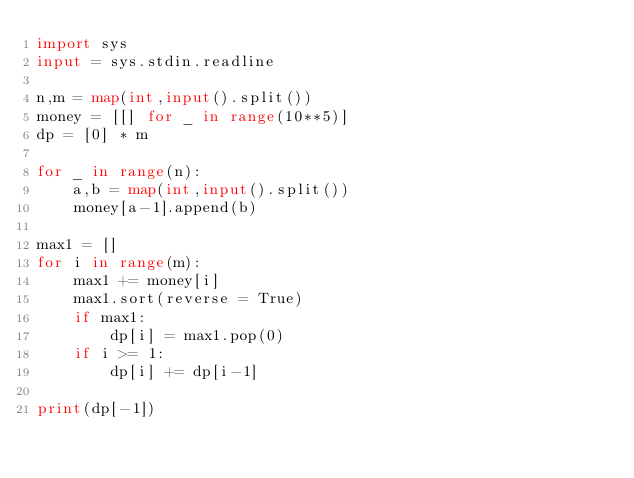Convert code to text. <code><loc_0><loc_0><loc_500><loc_500><_Python_>import sys
input = sys.stdin.readline

n,m = map(int,input().split())
money = [[] for _ in range(10**5)]
dp = [0] * m

for _ in range(n):
    a,b = map(int,input().split())
    money[a-1].append(b)

max1 = []
for i in range(m):
    max1 += money[i]
    max1.sort(reverse = True)
    if max1:
        dp[i] = max1.pop(0)
    if i >= 1:
        dp[i] += dp[i-1]

print(dp[-1])
</code> 